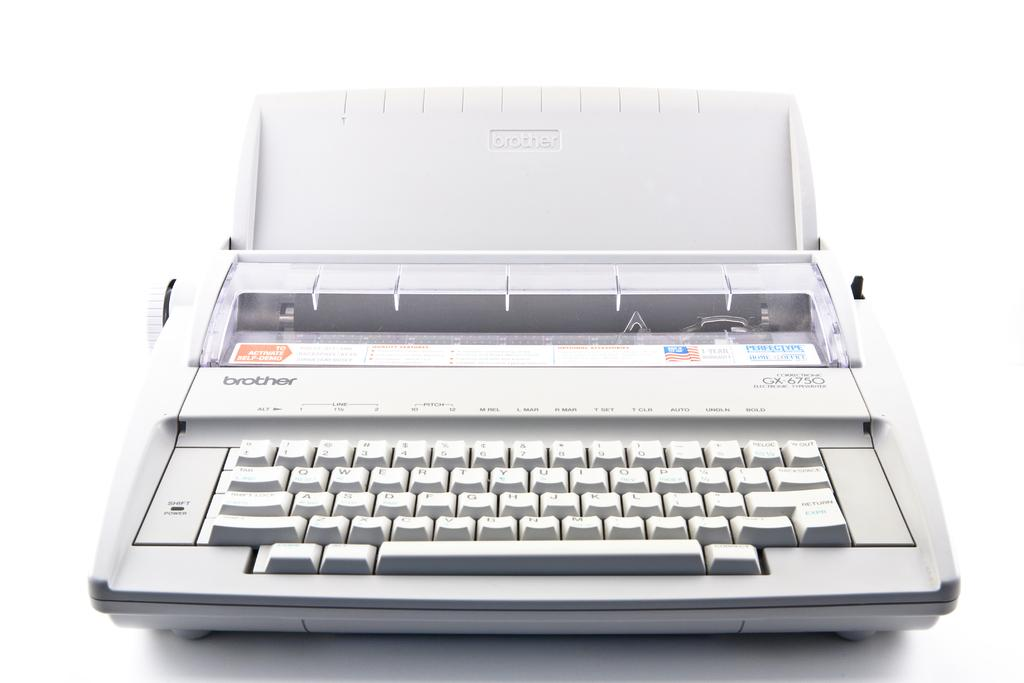<image>
Present a compact description of the photo's key features. a white, Brother typewriter has no paper in it. 